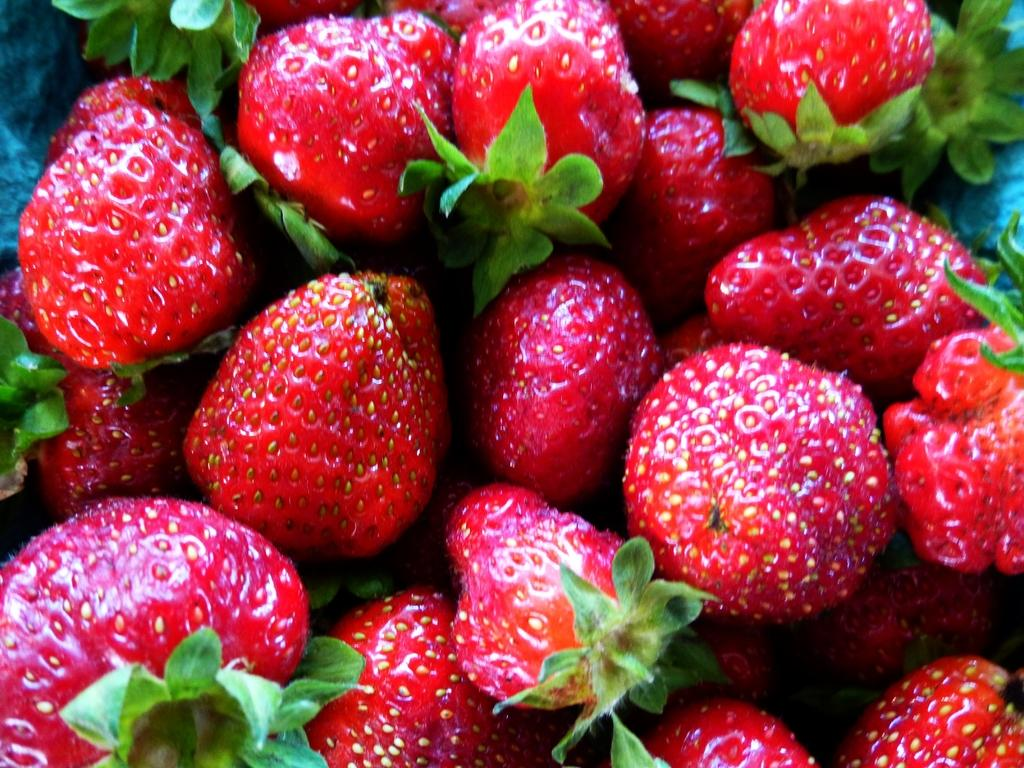What type of fruit is present in the image? There are strawberries in the image. What type of battle is taking place in the image? There is no battle present in the image; it only features strawberries. How many doors can be seen in the image? There are no doors present in the image; it only features strawberries. 